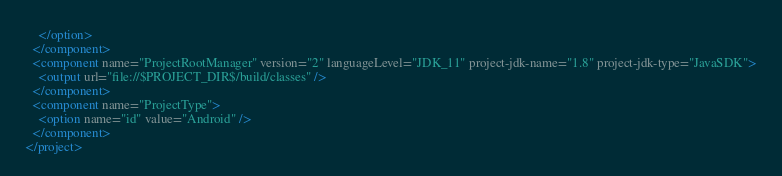<code> <loc_0><loc_0><loc_500><loc_500><_XML_>    </option>
  </component>
  <component name="ProjectRootManager" version="2" languageLevel="JDK_11" project-jdk-name="1.8" project-jdk-type="JavaSDK">
    <output url="file://$PROJECT_DIR$/build/classes" />
  </component>
  <component name="ProjectType">
    <option name="id" value="Android" />
  </component>
</project></code> 